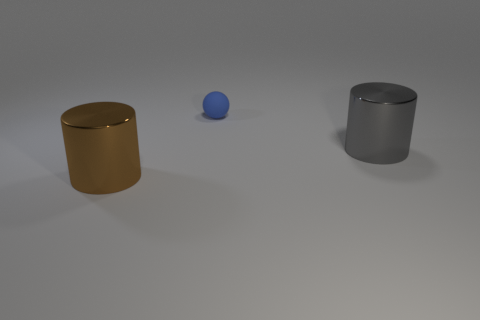Is there any other thing that has the same material as the small thing?
Keep it short and to the point. No. Are there an equal number of large gray objects that are to the left of the blue matte thing and tiny yellow matte blocks?
Your answer should be very brief. Yes. How big is the object that is both behind the brown thing and left of the big gray metallic cylinder?
Offer a terse response. Small. Are there any other things that have the same color as the small sphere?
Make the answer very short. No. There is a thing in front of the large thing that is right of the big brown cylinder; how big is it?
Offer a very short reply. Large. What is the color of the thing that is both in front of the matte sphere and behind the brown shiny object?
Provide a succinct answer. Gray. How many other objects are the same size as the blue object?
Provide a short and direct response. 0. There is a brown thing; is it the same size as the gray thing that is right of the rubber thing?
Your answer should be very brief. Yes. The cylinder that is the same size as the gray object is what color?
Make the answer very short. Brown. What is the size of the blue thing?
Your response must be concise. Small. 